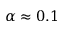<formula> <loc_0><loc_0><loc_500><loc_500>\alpha \approx 0 . 1</formula> 